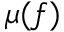<formula> <loc_0><loc_0><loc_500><loc_500>\mu ( f )</formula> 